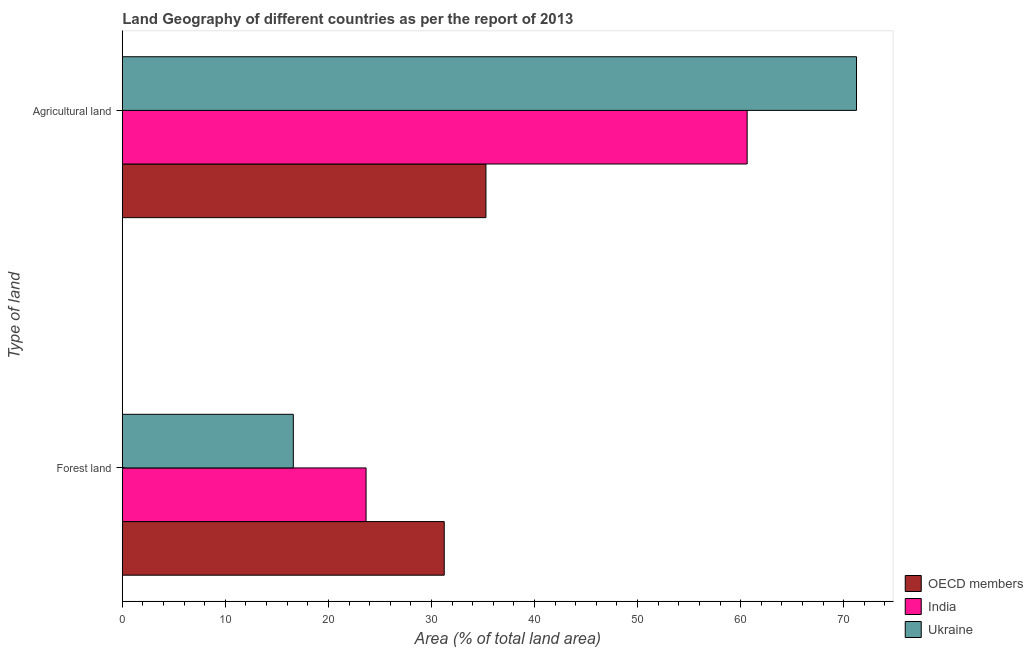How many different coloured bars are there?
Your answer should be compact. 3. How many groups of bars are there?
Give a very brief answer. 2. Are the number of bars on each tick of the Y-axis equal?
Provide a succinct answer. Yes. How many bars are there on the 1st tick from the top?
Offer a terse response. 3. What is the label of the 1st group of bars from the top?
Give a very brief answer. Agricultural land. What is the percentage of land area under agriculture in Ukraine?
Offer a very short reply. 71.25. Across all countries, what is the maximum percentage of land area under agriculture?
Provide a short and direct response. 71.25. Across all countries, what is the minimum percentage of land area under forests?
Your answer should be compact. 16.59. In which country was the percentage of land area under forests minimum?
Offer a terse response. Ukraine. What is the total percentage of land area under forests in the graph?
Provide a short and direct response. 71.49. What is the difference between the percentage of land area under agriculture in Ukraine and that in OECD members?
Provide a succinct answer. 35.96. What is the difference between the percentage of land area under agriculture in OECD members and the percentage of land area under forests in Ukraine?
Keep it short and to the point. 18.69. What is the average percentage of land area under agriculture per country?
Offer a terse response. 55.72. What is the difference between the percentage of land area under forests and percentage of land area under agriculture in OECD members?
Ensure brevity in your answer.  -4.05. What is the ratio of the percentage of land area under forests in India to that in Ukraine?
Provide a short and direct response. 1.43. What does the 1st bar from the top in Agricultural land represents?
Offer a very short reply. Ukraine. What does the 3rd bar from the bottom in Agricultural land represents?
Provide a short and direct response. Ukraine. How many bars are there?
Offer a very short reply. 6. Are all the bars in the graph horizontal?
Your answer should be compact. Yes. What is the difference between two consecutive major ticks on the X-axis?
Your response must be concise. 10. Are the values on the major ticks of X-axis written in scientific E-notation?
Your answer should be very brief. No. Does the graph contain grids?
Provide a succinct answer. No. How many legend labels are there?
Give a very brief answer. 3. What is the title of the graph?
Offer a terse response. Land Geography of different countries as per the report of 2013. What is the label or title of the X-axis?
Your response must be concise. Area (% of total land area). What is the label or title of the Y-axis?
Give a very brief answer. Type of land. What is the Area (% of total land area) of OECD members in Forest land?
Provide a succinct answer. 31.24. What is the Area (% of total land area) of India in Forest land?
Offer a terse response. 23.65. What is the Area (% of total land area) of Ukraine in Forest land?
Keep it short and to the point. 16.59. What is the Area (% of total land area) in OECD members in Agricultural land?
Give a very brief answer. 35.29. What is the Area (% of total land area) in India in Agricultural land?
Offer a terse response. 60.64. What is the Area (% of total land area) in Ukraine in Agricultural land?
Your answer should be compact. 71.25. Across all Type of land, what is the maximum Area (% of total land area) in OECD members?
Give a very brief answer. 35.29. Across all Type of land, what is the maximum Area (% of total land area) of India?
Your answer should be very brief. 60.64. Across all Type of land, what is the maximum Area (% of total land area) of Ukraine?
Ensure brevity in your answer.  71.25. Across all Type of land, what is the minimum Area (% of total land area) in OECD members?
Give a very brief answer. 31.24. Across all Type of land, what is the minimum Area (% of total land area) in India?
Give a very brief answer. 23.65. Across all Type of land, what is the minimum Area (% of total land area) of Ukraine?
Your answer should be compact. 16.59. What is the total Area (% of total land area) in OECD members in the graph?
Give a very brief answer. 66.53. What is the total Area (% of total land area) in India in the graph?
Your answer should be compact. 84.29. What is the total Area (% of total land area) of Ukraine in the graph?
Your answer should be compact. 87.84. What is the difference between the Area (% of total land area) in OECD members in Forest land and that in Agricultural land?
Provide a short and direct response. -4.05. What is the difference between the Area (% of total land area) of India in Forest land and that in Agricultural land?
Offer a very short reply. -36.98. What is the difference between the Area (% of total land area) in Ukraine in Forest land and that in Agricultural land?
Give a very brief answer. -54.65. What is the difference between the Area (% of total land area) of OECD members in Forest land and the Area (% of total land area) of India in Agricultural land?
Your answer should be compact. -29.4. What is the difference between the Area (% of total land area) in OECD members in Forest land and the Area (% of total land area) in Ukraine in Agricultural land?
Offer a terse response. -40.01. What is the difference between the Area (% of total land area) in India in Forest land and the Area (% of total land area) in Ukraine in Agricultural land?
Provide a succinct answer. -47.59. What is the average Area (% of total land area) in OECD members per Type of land?
Ensure brevity in your answer.  33.26. What is the average Area (% of total land area) of India per Type of land?
Your answer should be compact. 42.14. What is the average Area (% of total land area) in Ukraine per Type of land?
Keep it short and to the point. 43.92. What is the difference between the Area (% of total land area) in OECD members and Area (% of total land area) in India in Forest land?
Make the answer very short. 7.59. What is the difference between the Area (% of total land area) in OECD members and Area (% of total land area) in Ukraine in Forest land?
Provide a short and direct response. 14.64. What is the difference between the Area (% of total land area) of India and Area (% of total land area) of Ukraine in Forest land?
Offer a very short reply. 7.06. What is the difference between the Area (% of total land area) in OECD members and Area (% of total land area) in India in Agricultural land?
Provide a succinct answer. -25.35. What is the difference between the Area (% of total land area) of OECD members and Area (% of total land area) of Ukraine in Agricultural land?
Give a very brief answer. -35.96. What is the difference between the Area (% of total land area) of India and Area (% of total land area) of Ukraine in Agricultural land?
Make the answer very short. -10.61. What is the ratio of the Area (% of total land area) of OECD members in Forest land to that in Agricultural land?
Keep it short and to the point. 0.89. What is the ratio of the Area (% of total land area) in India in Forest land to that in Agricultural land?
Offer a very short reply. 0.39. What is the ratio of the Area (% of total land area) in Ukraine in Forest land to that in Agricultural land?
Make the answer very short. 0.23. What is the difference between the highest and the second highest Area (% of total land area) of OECD members?
Ensure brevity in your answer.  4.05. What is the difference between the highest and the second highest Area (% of total land area) of India?
Ensure brevity in your answer.  36.98. What is the difference between the highest and the second highest Area (% of total land area) in Ukraine?
Make the answer very short. 54.65. What is the difference between the highest and the lowest Area (% of total land area) in OECD members?
Offer a terse response. 4.05. What is the difference between the highest and the lowest Area (% of total land area) of India?
Ensure brevity in your answer.  36.98. What is the difference between the highest and the lowest Area (% of total land area) of Ukraine?
Make the answer very short. 54.65. 